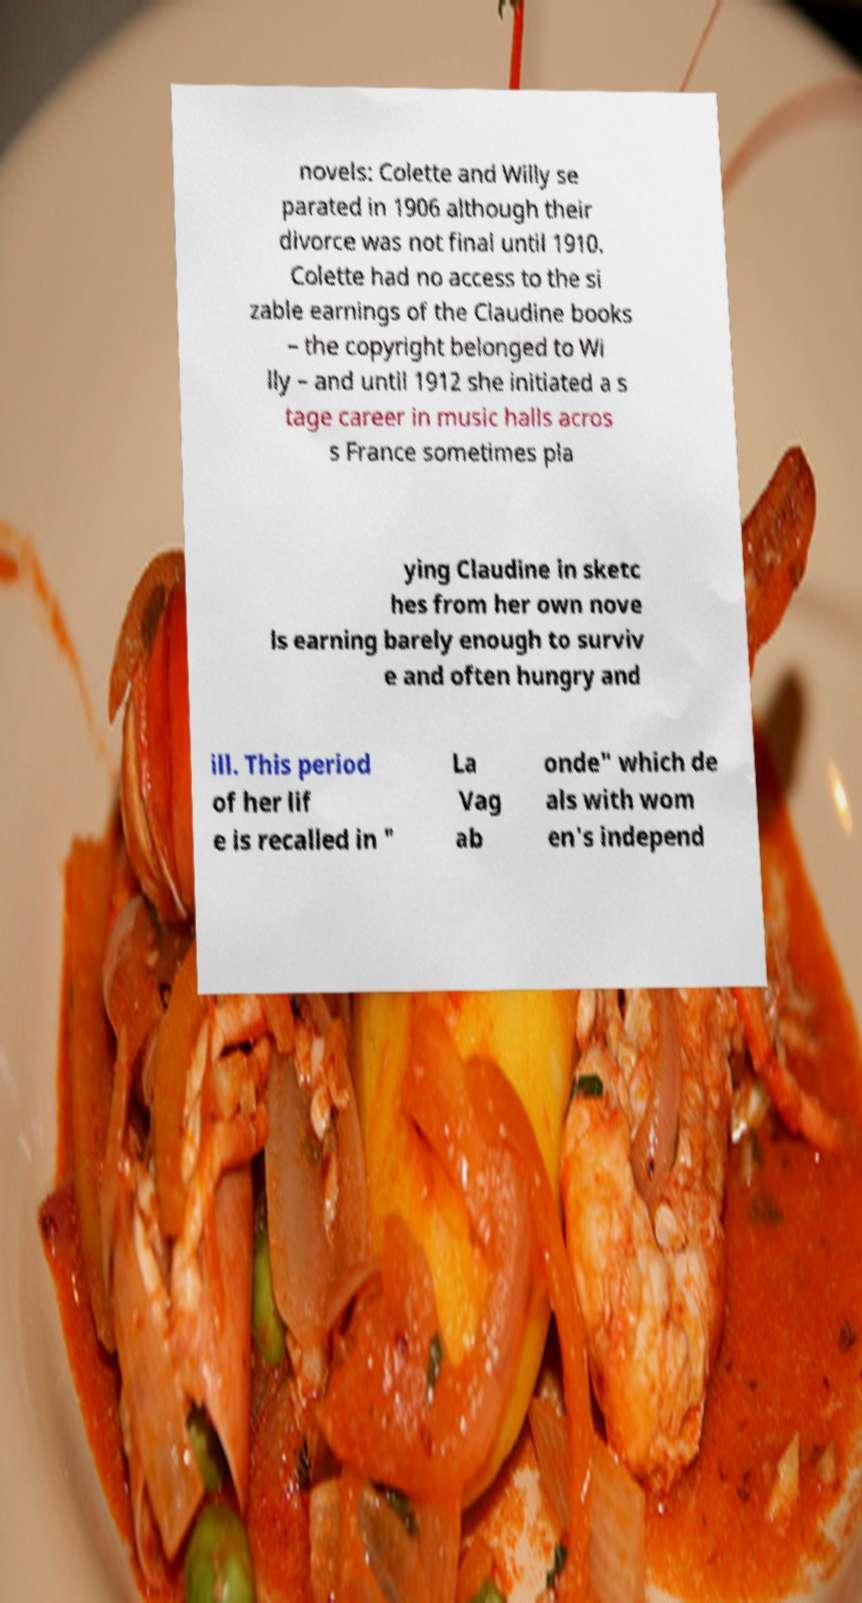Could you assist in decoding the text presented in this image and type it out clearly? novels: Colette and Willy se parated in 1906 although their divorce was not final until 1910. Colette had no access to the si zable earnings of the Claudine books – the copyright belonged to Wi lly – and until 1912 she initiated a s tage career in music halls acros s France sometimes pla ying Claudine in sketc hes from her own nove ls earning barely enough to surviv e and often hungry and ill. This period of her lif e is recalled in " La Vag ab onde" which de als with wom en's independ 